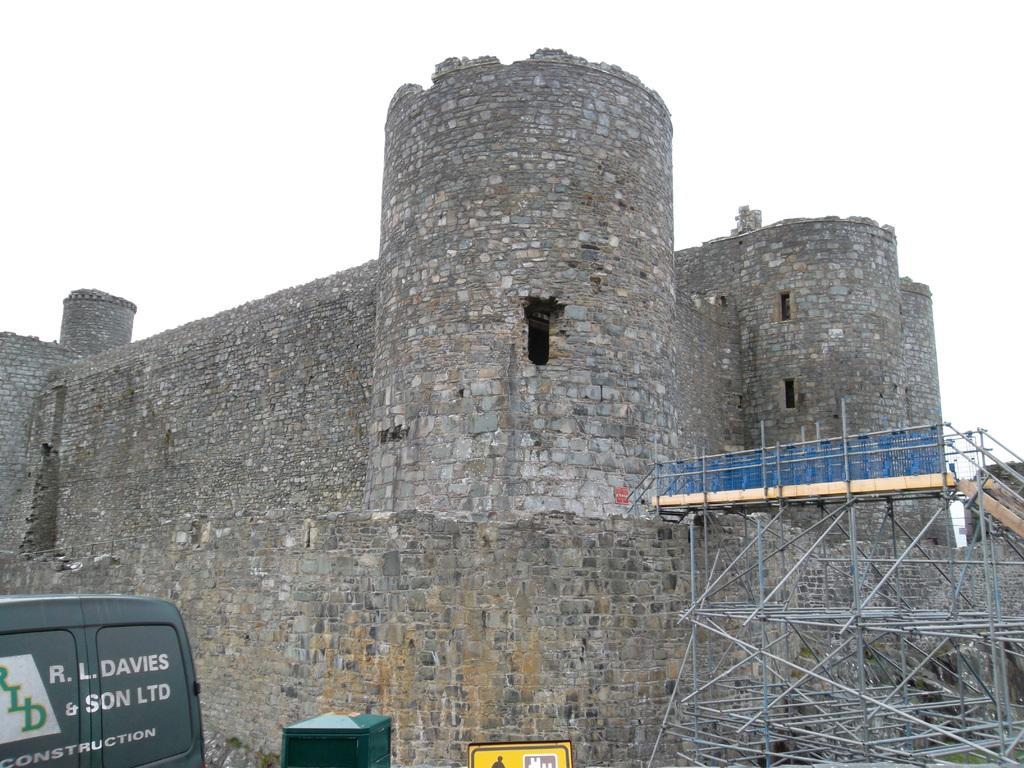Please provide a concise description of this image. In this picture I can see the fort. I can see the metal objects on the right side. I can see the vehicle on the left side. 